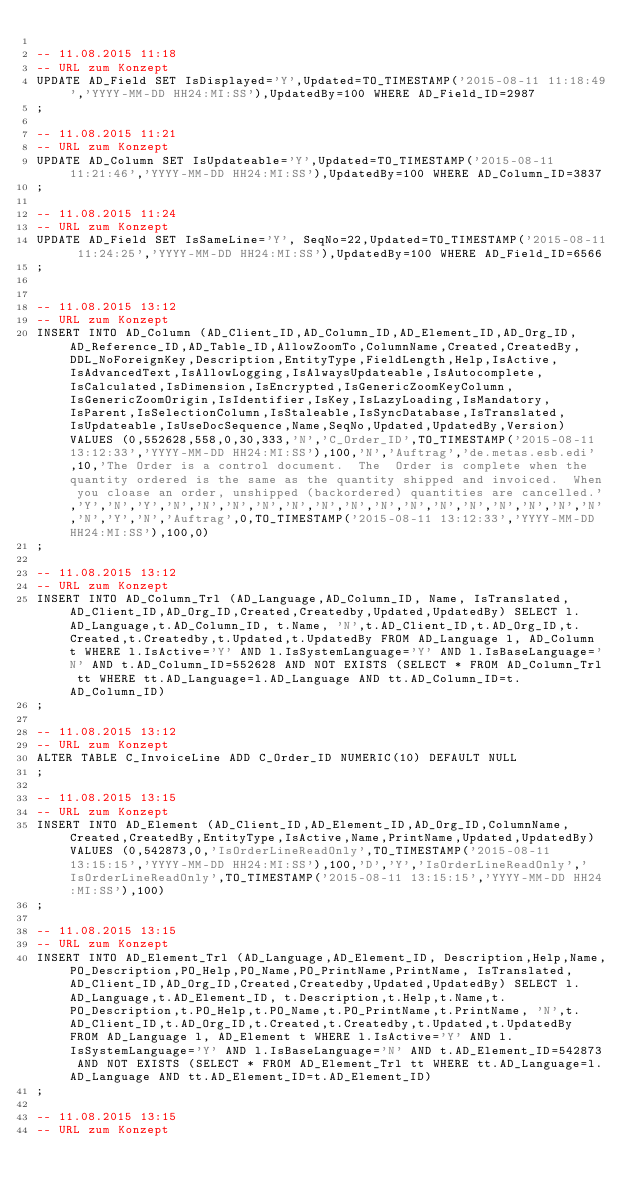Convert code to text. <code><loc_0><loc_0><loc_500><loc_500><_SQL_>
-- 11.08.2015 11:18
-- URL zum Konzept
UPDATE AD_Field SET IsDisplayed='Y',Updated=TO_TIMESTAMP('2015-08-11 11:18:49','YYYY-MM-DD HH24:MI:SS'),UpdatedBy=100 WHERE AD_Field_ID=2987
;

-- 11.08.2015 11:21
-- URL zum Konzept
UPDATE AD_Column SET IsUpdateable='Y',Updated=TO_TIMESTAMP('2015-08-11 11:21:46','YYYY-MM-DD HH24:MI:SS'),UpdatedBy=100 WHERE AD_Column_ID=3837
;

-- 11.08.2015 11:24
-- URL zum Konzept
UPDATE AD_Field SET IsSameLine='Y', SeqNo=22,Updated=TO_TIMESTAMP('2015-08-11 11:24:25','YYYY-MM-DD HH24:MI:SS'),UpdatedBy=100 WHERE AD_Field_ID=6566
;


-- 11.08.2015 13:12
-- URL zum Konzept
INSERT INTO AD_Column (AD_Client_ID,AD_Column_ID,AD_Element_ID,AD_Org_ID,AD_Reference_ID,AD_Table_ID,AllowZoomTo,ColumnName,Created,CreatedBy,DDL_NoForeignKey,Description,EntityType,FieldLength,Help,IsActive,IsAdvancedText,IsAllowLogging,IsAlwaysUpdateable,IsAutocomplete,IsCalculated,IsDimension,IsEncrypted,IsGenericZoomKeyColumn,IsGenericZoomOrigin,IsIdentifier,IsKey,IsLazyLoading,IsMandatory,IsParent,IsSelectionColumn,IsStaleable,IsSyncDatabase,IsTranslated,IsUpdateable,IsUseDocSequence,Name,SeqNo,Updated,UpdatedBy,Version) VALUES (0,552628,558,0,30,333,'N','C_Order_ID',TO_TIMESTAMP('2015-08-11 13:12:33','YYYY-MM-DD HH24:MI:SS'),100,'N','Auftrag','de.metas.esb.edi',10,'The Order is a control document.  The  Order is complete when the quantity ordered is the same as the quantity shipped and invoiced.  When you cloase an order, unshipped (backordered) quantities are cancelled.','Y','N','Y','N','N','N','N','N','N','N','N','N','N','N','N','N','N','N','N','Y','N','Auftrag',0,TO_TIMESTAMP('2015-08-11 13:12:33','YYYY-MM-DD HH24:MI:SS'),100,0)
;

-- 11.08.2015 13:12
-- URL zum Konzept
INSERT INTO AD_Column_Trl (AD_Language,AD_Column_ID, Name, IsTranslated,AD_Client_ID,AD_Org_ID,Created,Createdby,Updated,UpdatedBy) SELECT l.AD_Language,t.AD_Column_ID, t.Name, 'N',t.AD_Client_ID,t.AD_Org_ID,t.Created,t.Createdby,t.Updated,t.UpdatedBy FROM AD_Language l, AD_Column t WHERE l.IsActive='Y' AND l.IsSystemLanguage='Y' AND l.IsBaseLanguage='N' AND t.AD_Column_ID=552628 AND NOT EXISTS (SELECT * FROM AD_Column_Trl tt WHERE tt.AD_Language=l.AD_Language AND tt.AD_Column_ID=t.AD_Column_ID)
;

-- 11.08.2015 13:12
-- URL zum Konzept
ALTER TABLE C_InvoiceLine ADD C_Order_ID NUMERIC(10) DEFAULT NULL 
;

-- 11.08.2015 13:15
-- URL zum Konzept
INSERT INTO AD_Element (AD_Client_ID,AD_Element_ID,AD_Org_ID,ColumnName,Created,CreatedBy,EntityType,IsActive,Name,PrintName,Updated,UpdatedBy) VALUES (0,542873,0,'IsOrderLineReadOnly',TO_TIMESTAMP('2015-08-11 13:15:15','YYYY-MM-DD HH24:MI:SS'),100,'D','Y','IsOrderLineReadOnly','IsOrderLineReadOnly',TO_TIMESTAMP('2015-08-11 13:15:15','YYYY-MM-DD HH24:MI:SS'),100)
;

-- 11.08.2015 13:15
-- URL zum Konzept
INSERT INTO AD_Element_Trl (AD_Language,AD_Element_ID, Description,Help,Name,PO_Description,PO_Help,PO_Name,PO_PrintName,PrintName, IsTranslated,AD_Client_ID,AD_Org_ID,Created,Createdby,Updated,UpdatedBy) SELECT l.AD_Language,t.AD_Element_ID, t.Description,t.Help,t.Name,t.PO_Description,t.PO_Help,t.PO_Name,t.PO_PrintName,t.PrintName, 'N',t.AD_Client_ID,t.AD_Org_ID,t.Created,t.Createdby,t.Updated,t.UpdatedBy FROM AD_Language l, AD_Element t WHERE l.IsActive='Y' AND l.IsSystemLanguage='Y' AND l.IsBaseLanguage='N' AND t.AD_Element_ID=542873 AND NOT EXISTS (SELECT * FROM AD_Element_Trl tt WHERE tt.AD_Language=l.AD_Language AND tt.AD_Element_ID=t.AD_Element_ID)
;

-- 11.08.2015 13:15
-- URL zum Konzept</code> 